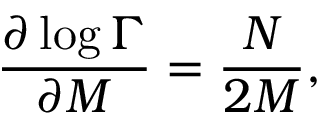<formula> <loc_0><loc_0><loc_500><loc_500>\frac { \partial \log { \Gamma } } { \partial M } = \frac { N } { 2 M } ,</formula> 